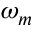<formula> <loc_0><loc_0><loc_500><loc_500>\omega _ { m }</formula> 